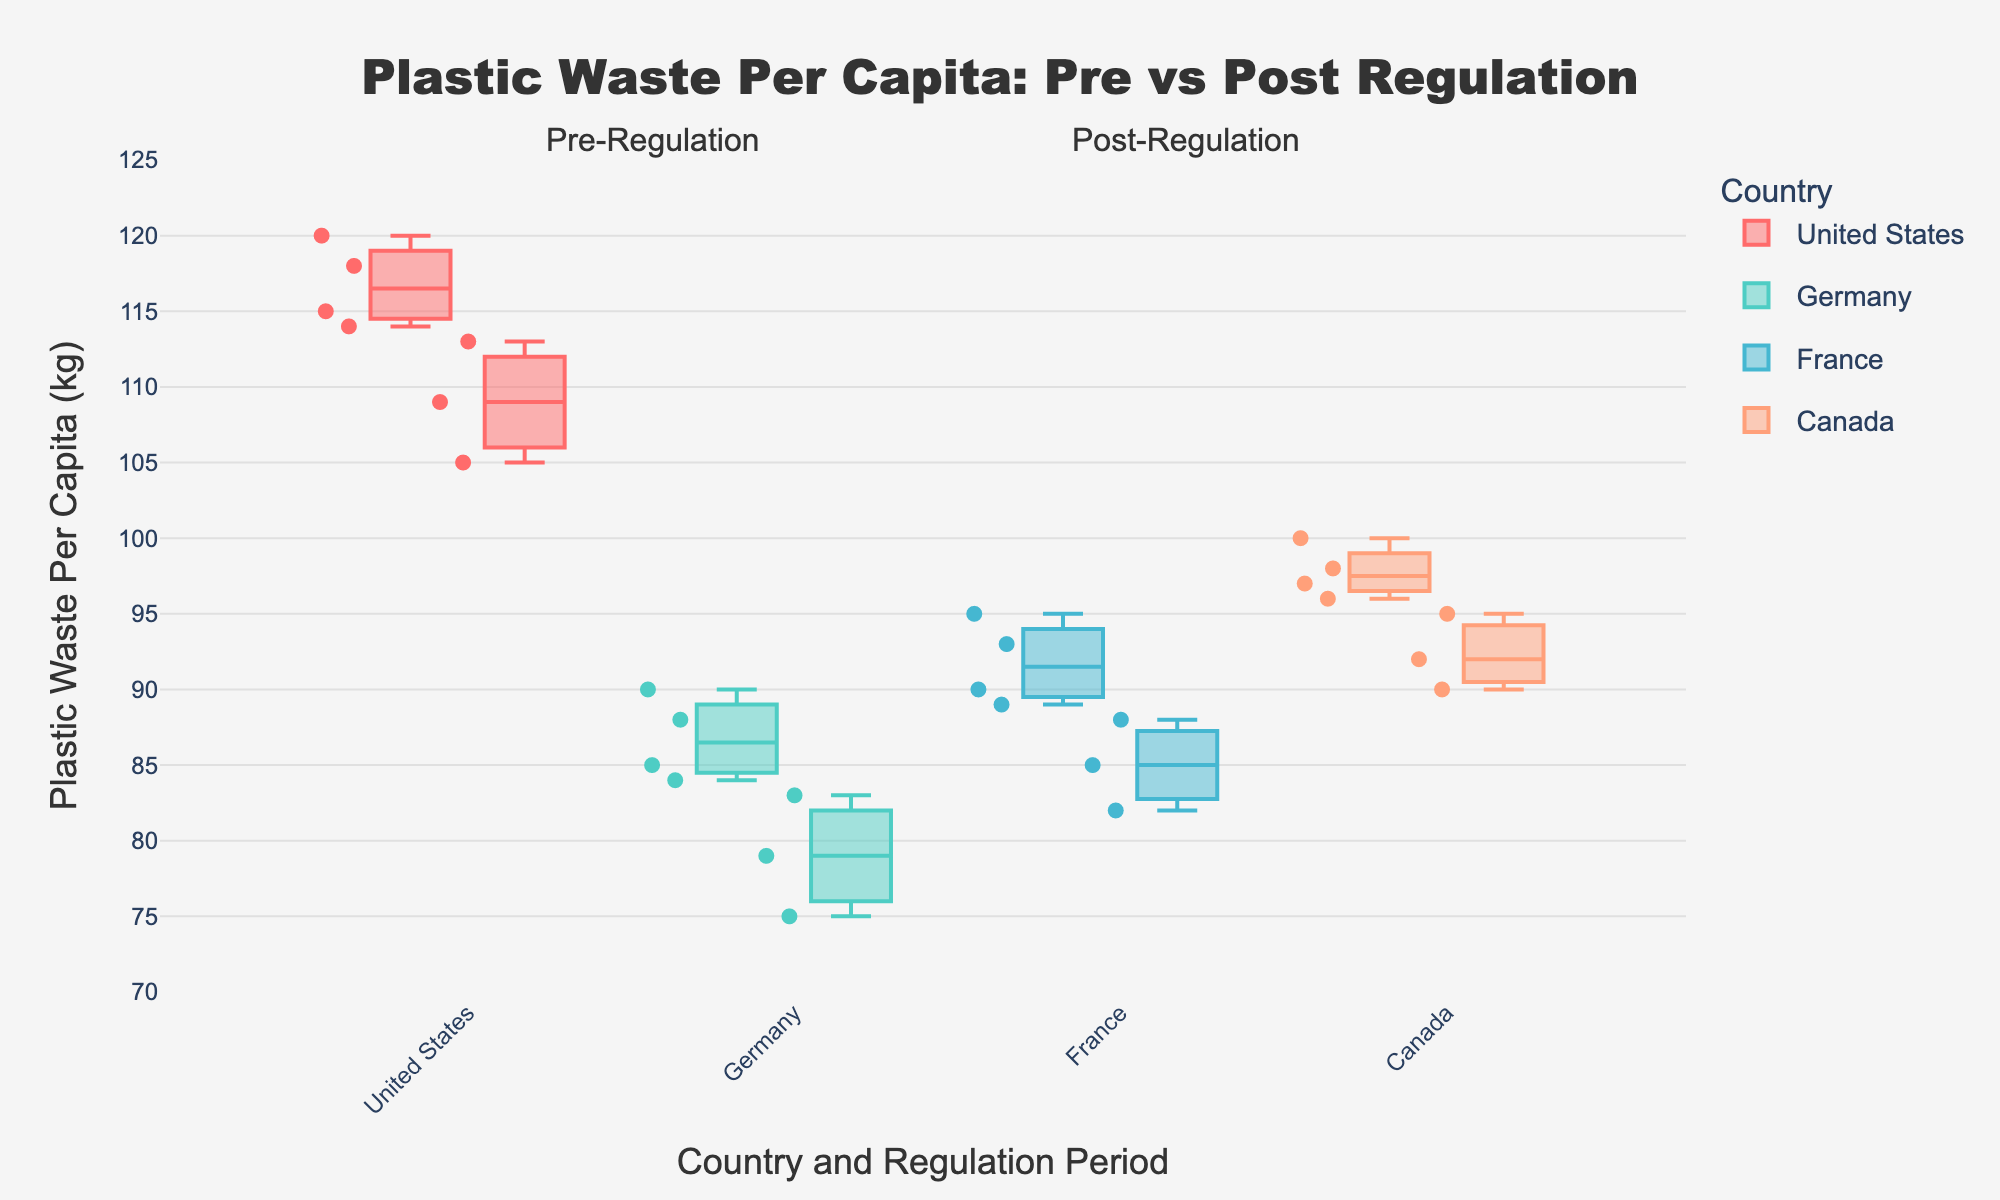What is the title of the plot? The title of the plot is prominently displayed at the top and provides an overview of what the plot is showing.
Answer: Plastic Waste Per Capita: Pre vs Post Regulation Which country had the highest plastic waste per capita post-regulation? Look at the box plot section labeled "Post-Regulation" and identify the country with the highest top whisker.
Answer: United States How does Germany's median plastic waste per capita compare pre- and post-regulation? Compare the median line within the boxes for Germany between the two periods.
Answer: Pre-regulation median is higher than post-regulation How many countries are represented in the plot? Count the distinct country names that appear in both Pre-Regulation and Post-Regulation sections.
Answer: Four Which country showed the greatest reduction in plastic waste per capita from pre- to post-regulation? Observe the difference between the median lines for each country before and after the regulation period. The country with the largest drop indicates the greatest reduction.
Answer: Germany For which country did the regulation seem to have the least impact? Compare the differences in median values between pre- and post-regulation periods for all countries. The smallest difference indicates the least impact.
Answer: United States What is the range of plastic waste per capita in Canada during the post-regulation period? Identify the range by noting the minimum and maximum values (from the whiskers) during the post-regulation period for Canada.
Answer: 90-95 kg How do the interquartile ranges (IQRs) of France's plastic waste per capita compare pre- and post-regulation? Look at the length of the boxes (which represent the IQR) for France during both periods and compare their sizes.
Answer: The IQR for post-regulation is slightly narrower What trend can be observed in plastic waste per capita in all countries from pre- to post-regulation? Analyze and summarize the observed trends across all countries, noting whether the median values generally increase, decrease, or remain stable.
Answer: Generally decreasing Which country's post-regulation plastic waste per capita has the lowest variation? Observe the width of the boxes and the length of the whiskers among post-regulation data. The smallest range indicates the lowest variation.
Answer: France 